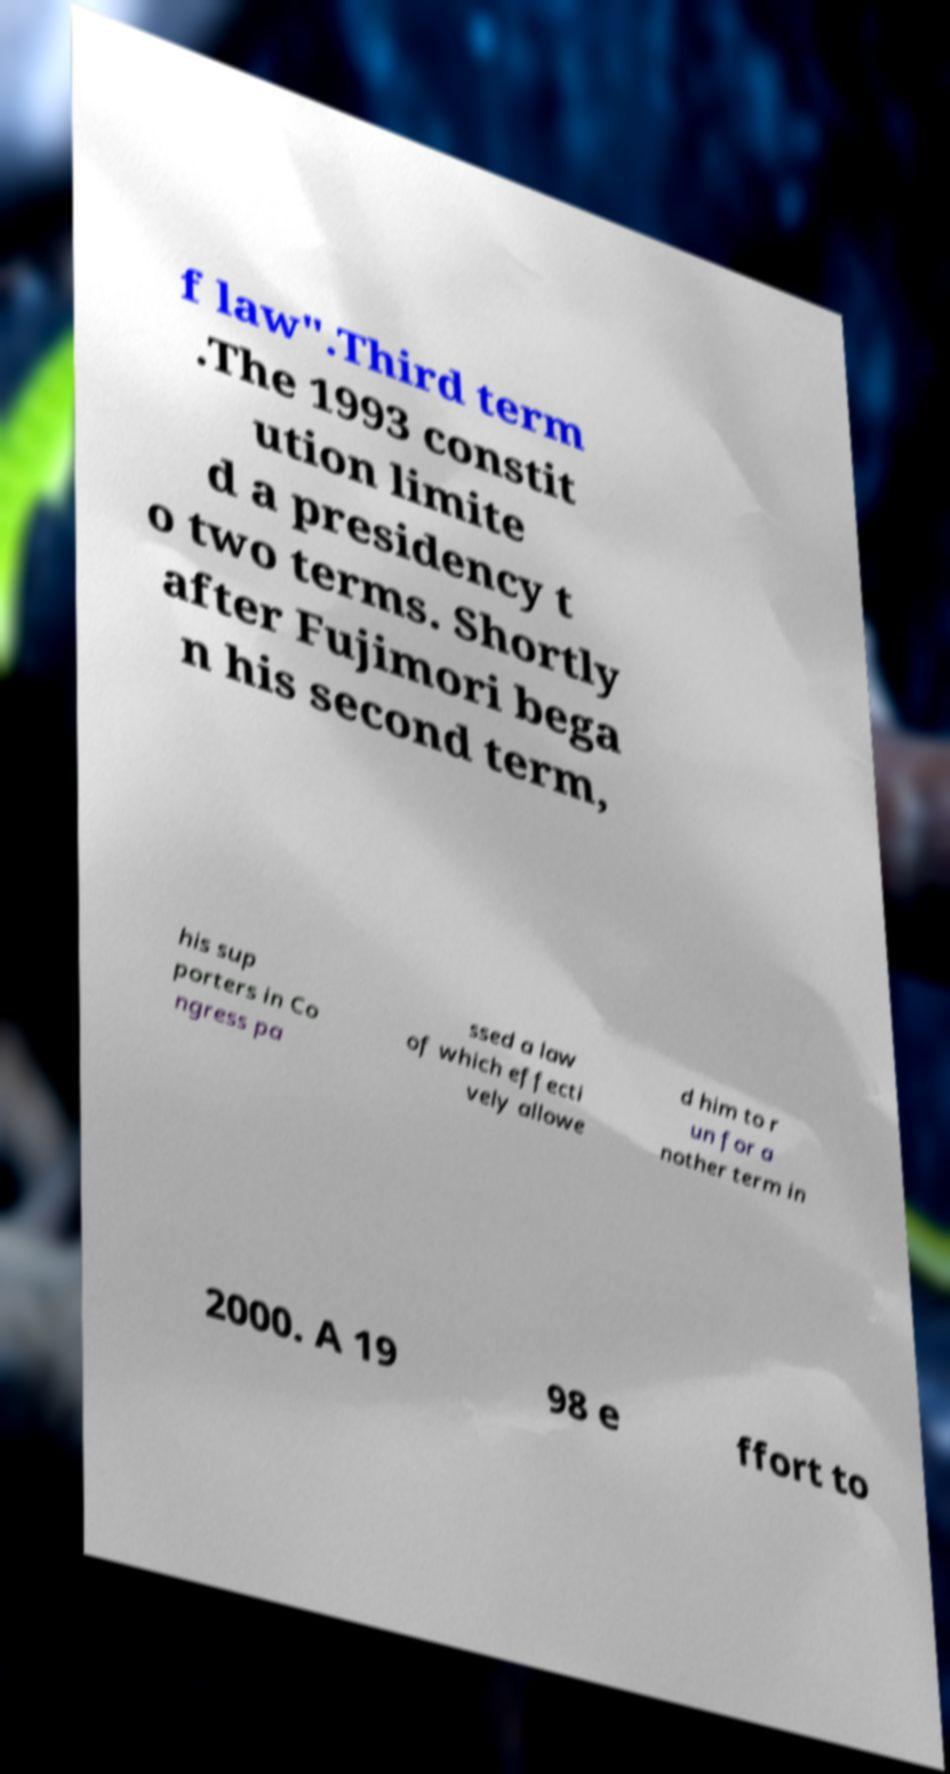There's text embedded in this image that I need extracted. Can you transcribe it verbatim? f law".Third term .The 1993 constit ution limite d a presidency t o two terms. Shortly after Fujimori bega n his second term, his sup porters in Co ngress pa ssed a law of which effecti vely allowe d him to r un for a nother term in 2000. A 19 98 e ffort to 